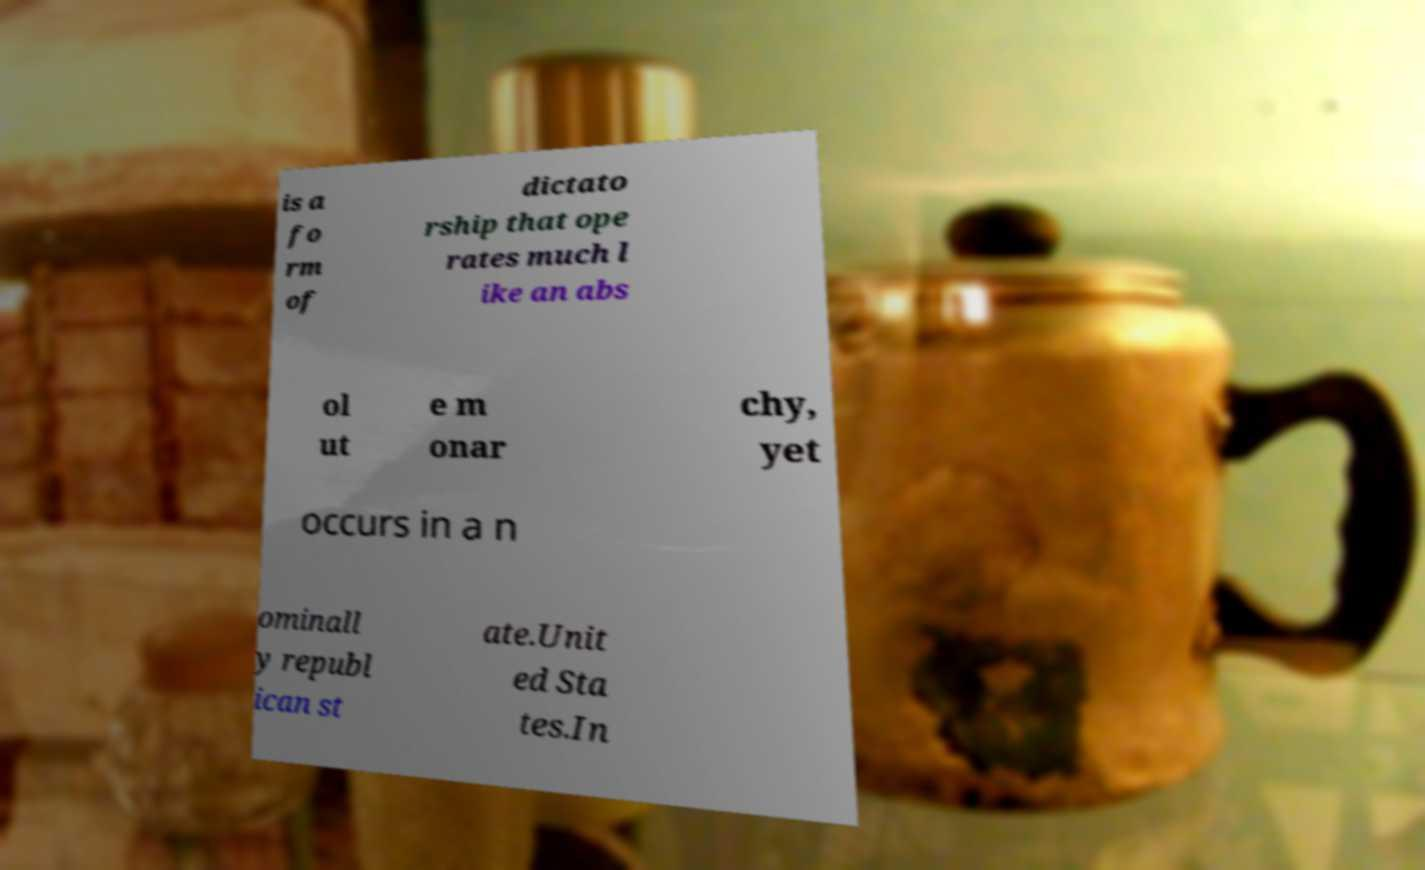For documentation purposes, I need the text within this image transcribed. Could you provide that? is a fo rm of dictato rship that ope rates much l ike an abs ol ut e m onar chy, yet occurs in a n ominall y republ ican st ate.Unit ed Sta tes.In 